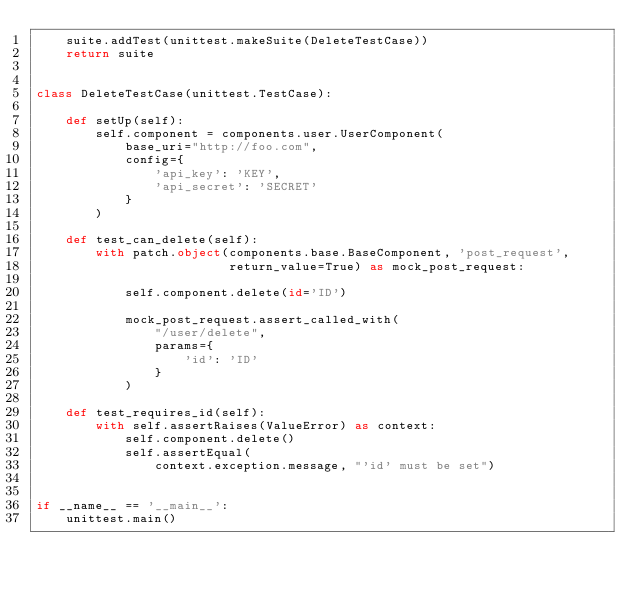<code> <loc_0><loc_0><loc_500><loc_500><_Python_>    suite.addTest(unittest.makeSuite(DeleteTestCase))
    return suite


class DeleteTestCase(unittest.TestCase):

    def setUp(self):
        self.component = components.user.UserComponent(
            base_uri="http://foo.com",
            config={
                'api_key': 'KEY',
                'api_secret': 'SECRET'
            }
        )

    def test_can_delete(self):
        with patch.object(components.base.BaseComponent, 'post_request',
                          return_value=True) as mock_post_request:

            self.component.delete(id='ID')

            mock_post_request.assert_called_with(
                "/user/delete",
                params={
                    'id': 'ID'
                }
            )

    def test_requires_id(self):
        with self.assertRaises(ValueError) as context:
            self.component.delete()
            self.assertEqual(
                context.exception.message, "'id' must be set")


if __name__ == '__main__':
    unittest.main()
</code> 